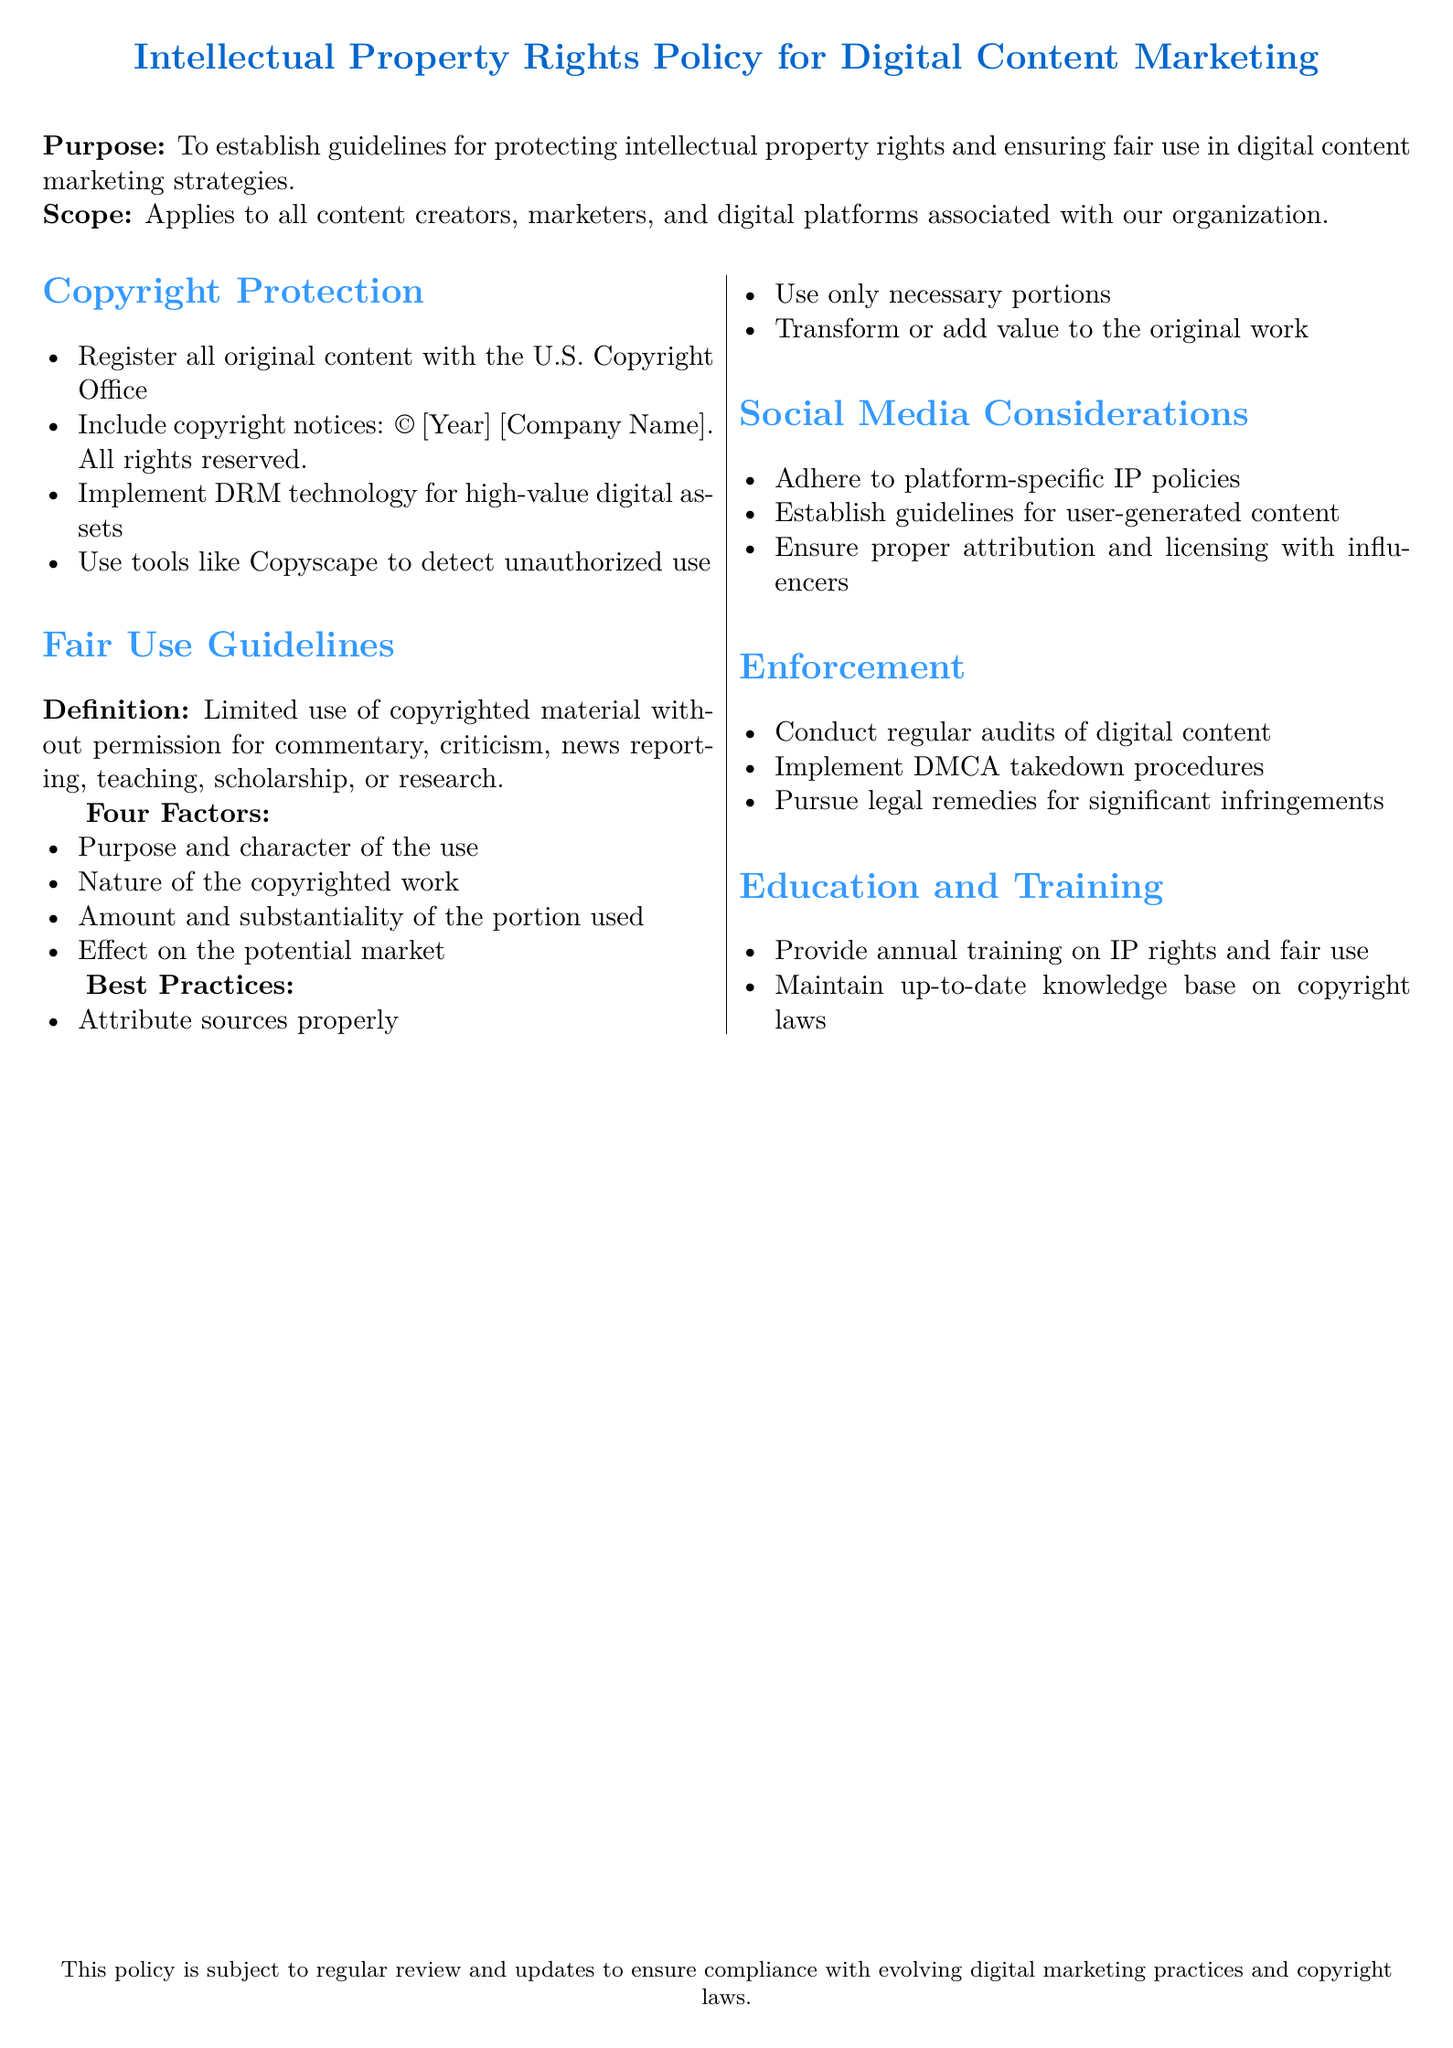What is the purpose of the document? The purpose is to establish guidelines for protecting intellectual property rights and ensuring fair use in digital content marketing strategies.
Answer: Establish guidelines for protecting intellectual property rights and ensuring fair use What should be included in copyright notices? The copyright notices should include the year and the company name.
Answer: © [Year] [Company Name]. All rights reserved What are the four factors of fair use? The four factors are purpose and character of use, nature of the copyrighted work, amount and substantiality of the portion used, and effect on the potential market.
Answer: Purpose and character of the use, nature of the copyrighted work, amount and substantiality of the portion used, effect on the potential market What is one method mentioned for detecting unauthorized use? One method mentioned is the use of Copyscape.
Answer: Copyscape What type of training is provided annually? The training provided is on intellectual property rights and fair use.
Answer: Training on IP rights and fair use What is the primary enforcement action mentioned in the document? The primary enforcement action is to conduct regular audits of digital content.
Answer: Conduct regular audits of digital content What should content creators do with user-generated content? Content creators should establish guidelines for user-generated content.
Answer: Establish guidelines for user-generated content What technology should be implemented for high-value digital assets? The document mentions implementing DRM technology.
Answer: DRM technology 